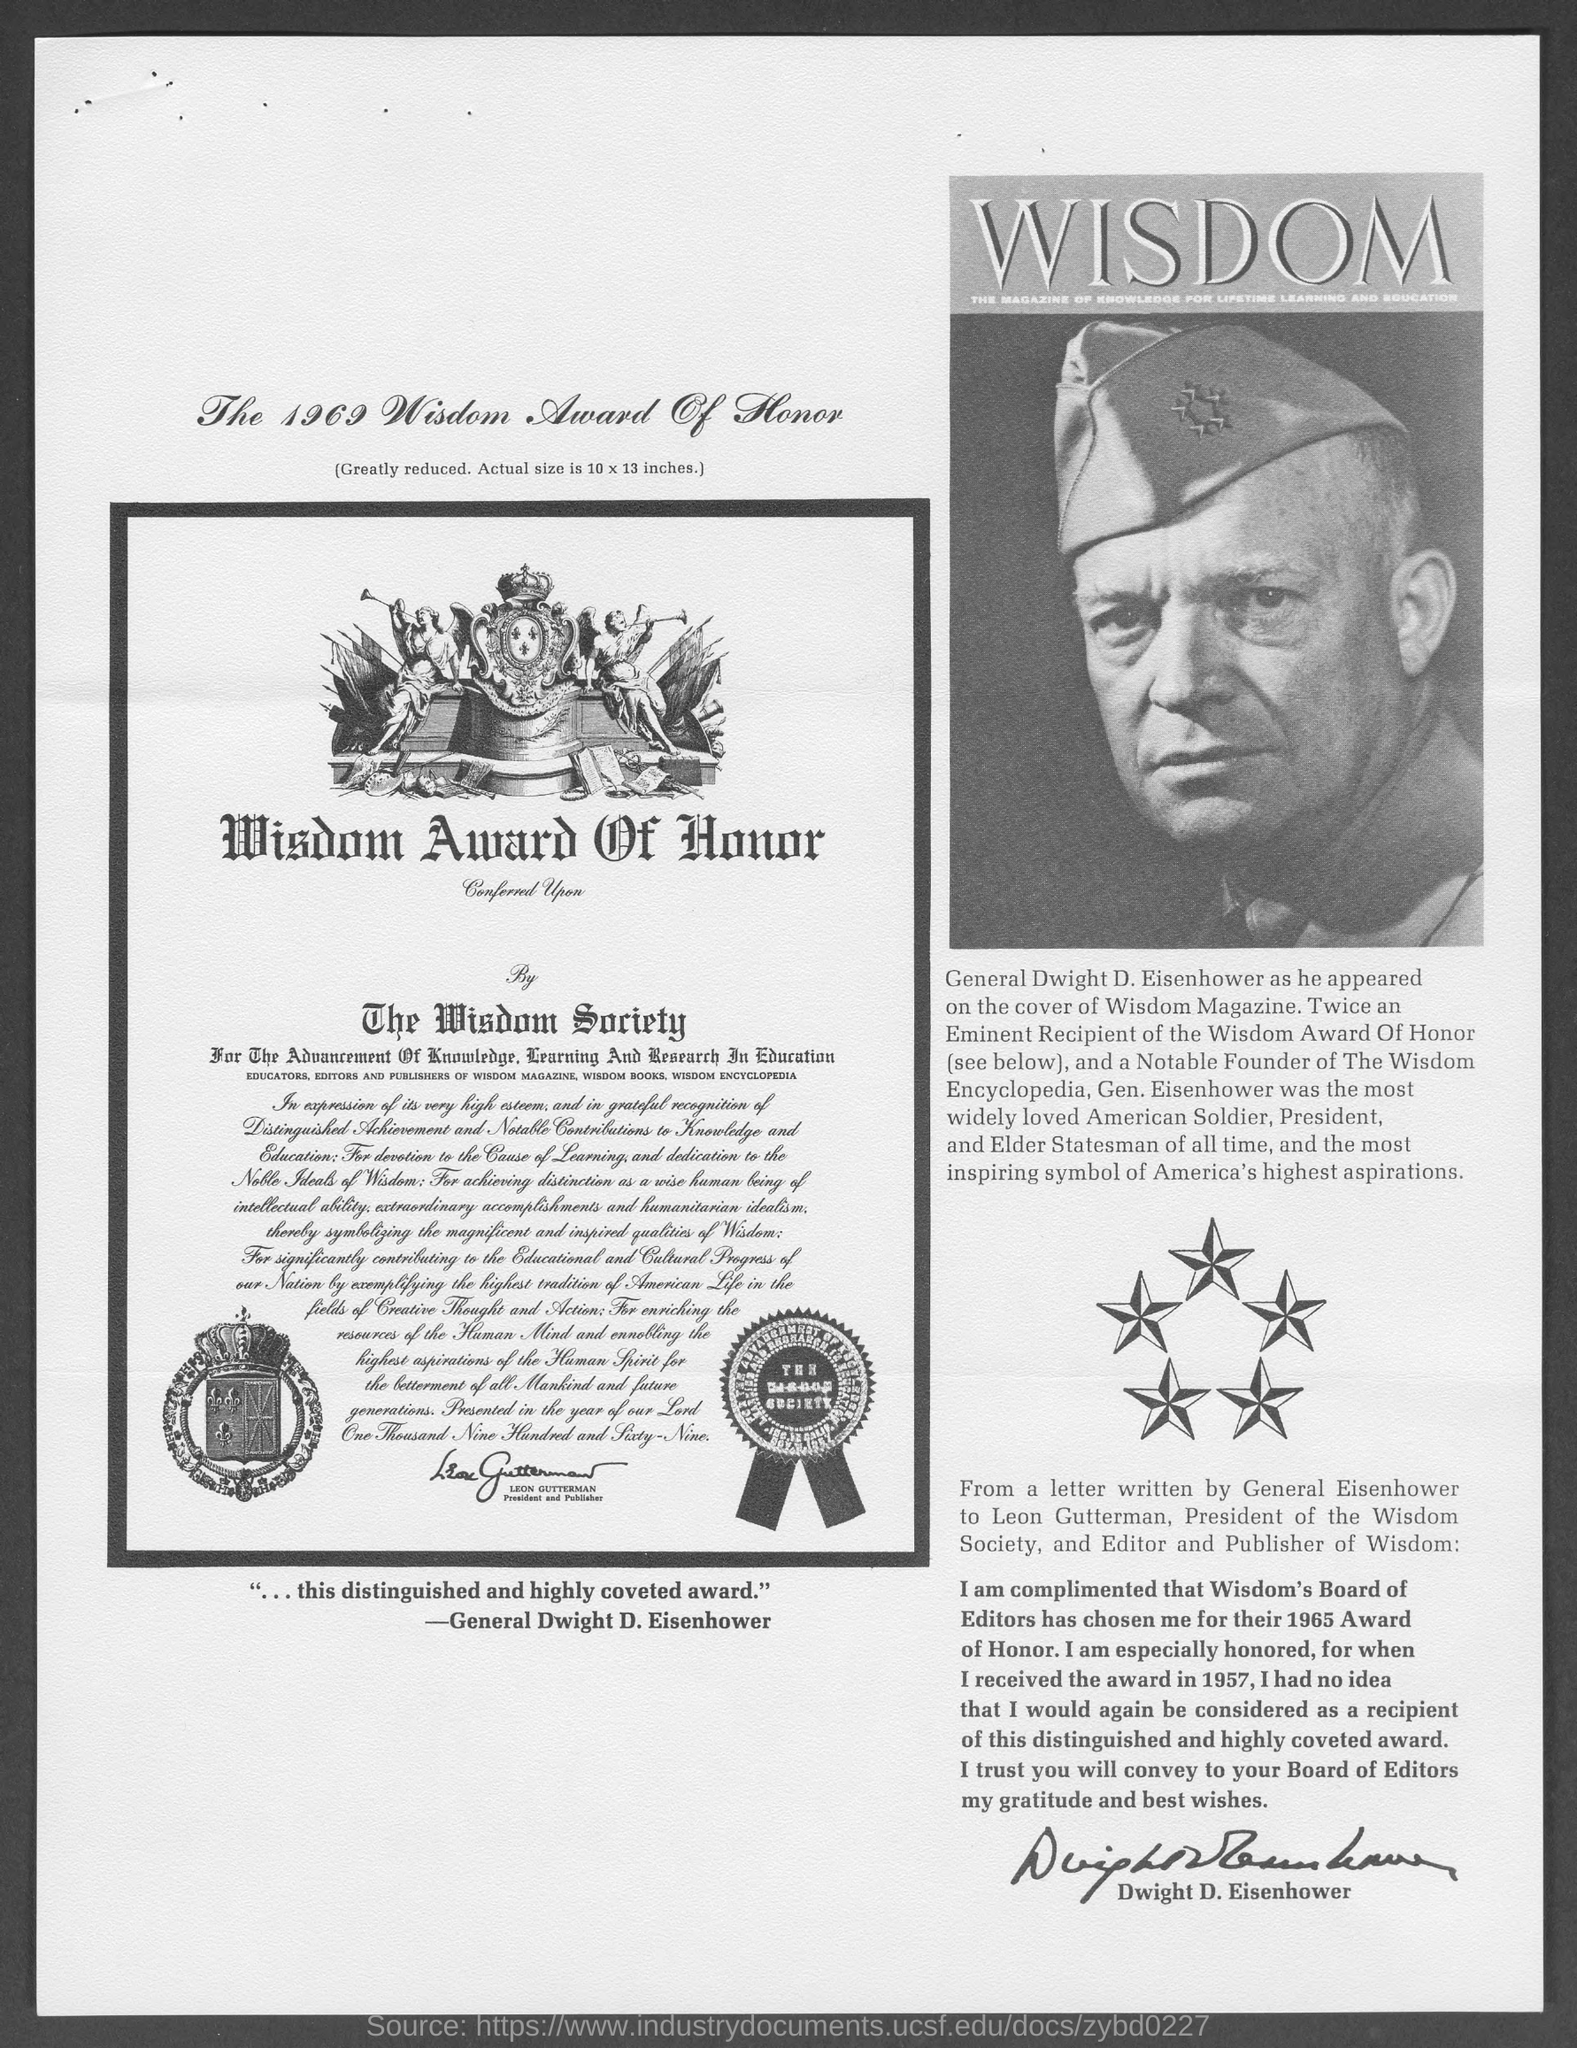What is the year of Wisdom Award Of Honor?
Offer a very short reply. 1969. Who was the most widely loved American Soldier?
Your response must be concise. Gen. Eisenhower. 